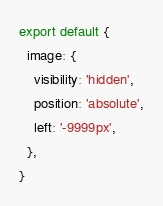Convert code to text. <code><loc_0><loc_0><loc_500><loc_500><_JavaScript_>export default {
  image: {
    visibility: 'hidden',
    position: 'absolute',
    left: '-9999px',
  },
}
</code> 